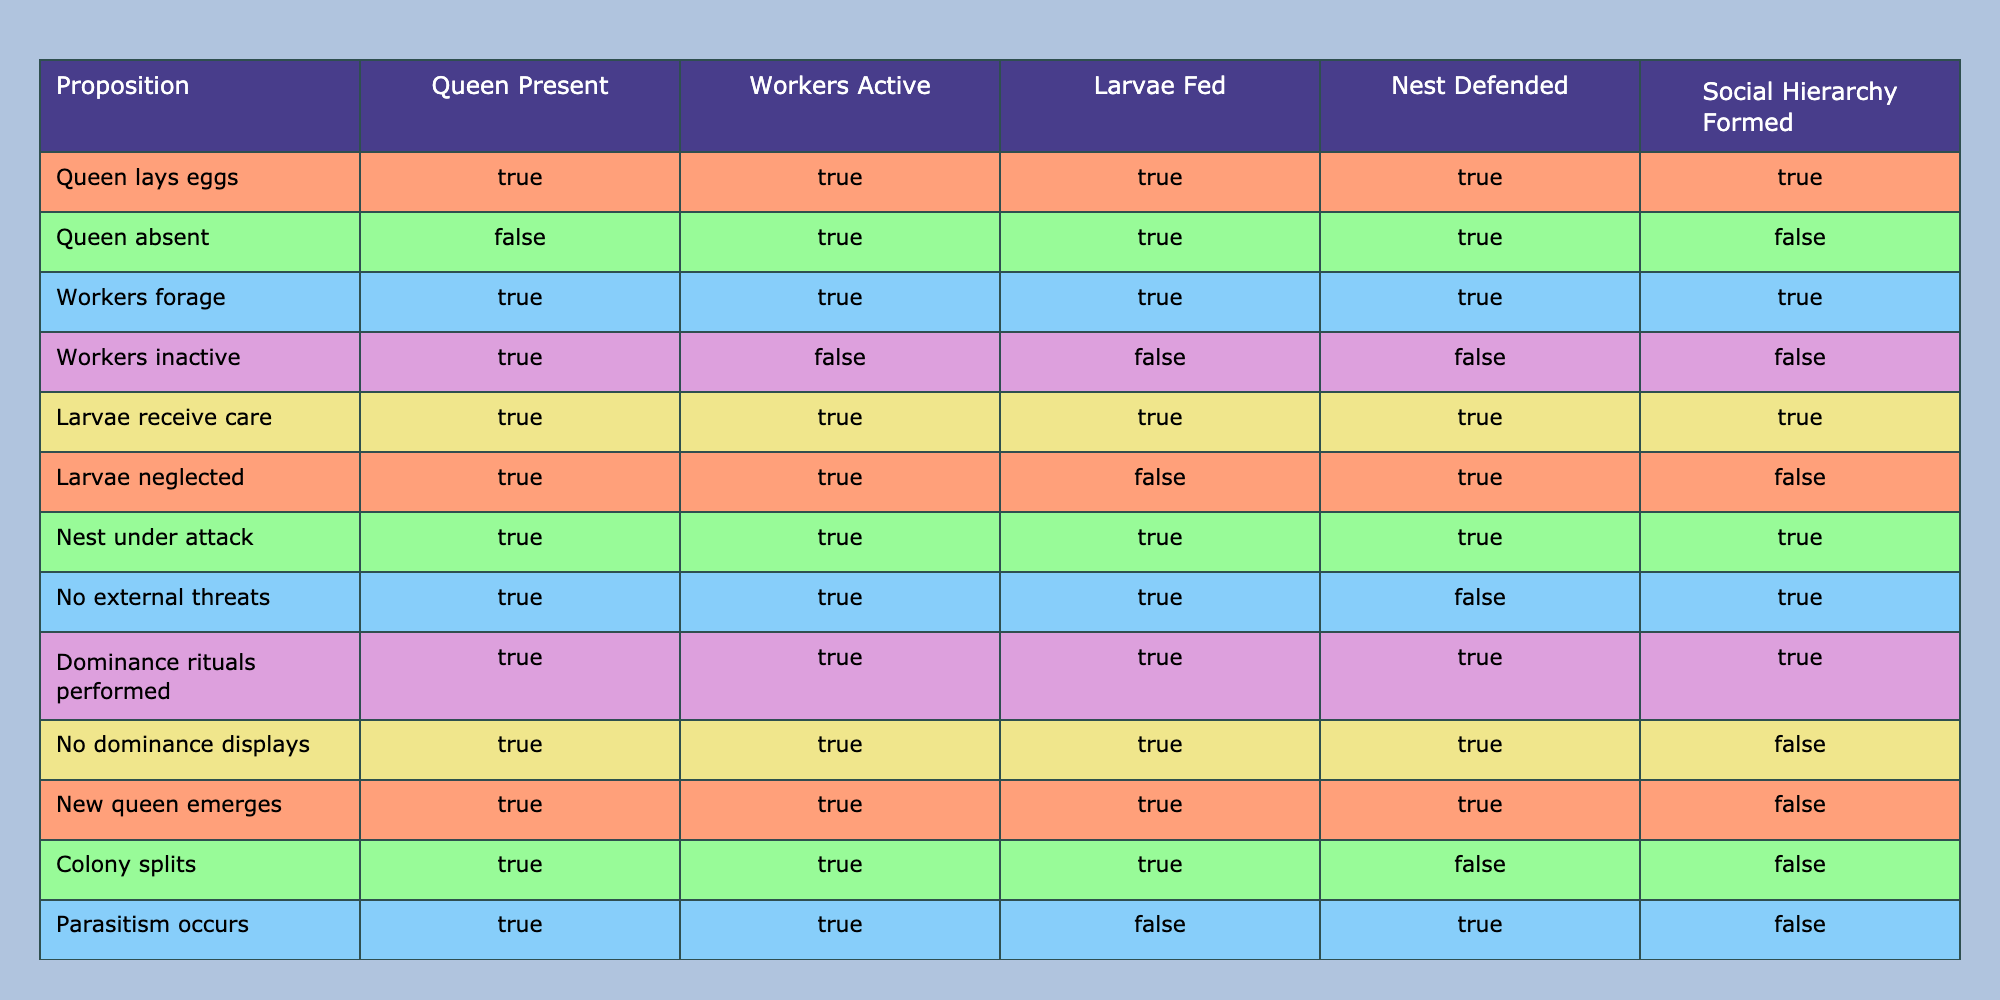What is the relationship between the presence of the queen and social hierarchy formation? According to the table, when the queen is present, the social hierarchy is formed (True in the first, third, seventh, ninth rows). However, when the queen is absent, the social hierarchy formation is False (second row). Therefore, the presence of the queen correlates positively with the formation of social hierarchy.
Answer: Positive correlation How many conditions lead to social hierarchy formation? By inspecting the table, the rows that show True for social hierarchy formation are the first, third, seventh, ninth, and seventh rows, which totals five conditions.
Answer: Five conditions Is it true that the presence of dominance rituals always leads to social hierarchy formation? The table shows that when dominance rituals are performed, the social hierarchy is indeed formed (ninth row). However, in the case of no dominance displays, the hierarchy formation is False (tenth row). Therefore, it can be concluded that dominance rituals are essential but not the only factor, making this statement False.
Answer: True What is the only condition under which larvae are neglected but the nest is still defended? In the table, the only instance of larvae being neglected (sixth row) alongside the nest being defended is seen in the row with "Larvae neglected" where the values indicate that it is nonetheless true the nest is defended, fulfilling the condition.
Answer: Larvae neglected If we summarize the conditions under which the nest is defended, how many are associated with active workers? Looking at the table, the instances where the nest is defended with active workers include the first, third, sixth, and seventh rows, counting four conditions implemented where workers are active (True).
Answer: Four conditions Can we conclude that seasonal changes prevent social hierarchy formation? The table indicates that during seasonal changes, the social hierarchy formed (row 12 shows True). Hence, we cannot conclude that seasonal changes prevent social hierarchy formation; instead, they can actually support it.
Answer: No In what scenario can you have a queen present but not have any active workers? Referring to the table, the scenario where the queen is present (first, seventh, ninth, or eighth rows) and there are no active workers is the row where 'Workers inactive' is True, showing that this condition can occur.
Answer: Workers inactive Which conditions can lead to the social hierarchy being formed without any external threats? The table indicates that when there are no external threats (eighth row), true for social hierarchy is formed. This realization means there is at least this singular condition where a social hierarchy can emerge without external threats.
Answer: One condition What is the implication of parasitism on the social hierarchy formation? The table reveals that when parasitism occurs (row 12), while the presence of the queen still allows for some worker activity and functional nest defense, the social hierarchy formation is False. This implies that parasitism significantly disrupts the potential for an established social structure in the colony.
Answer: Disruption of hierarchy formation 